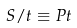Convert formula to latex. <formula><loc_0><loc_0><loc_500><loc_500>S / t \equiv P t</formula> 